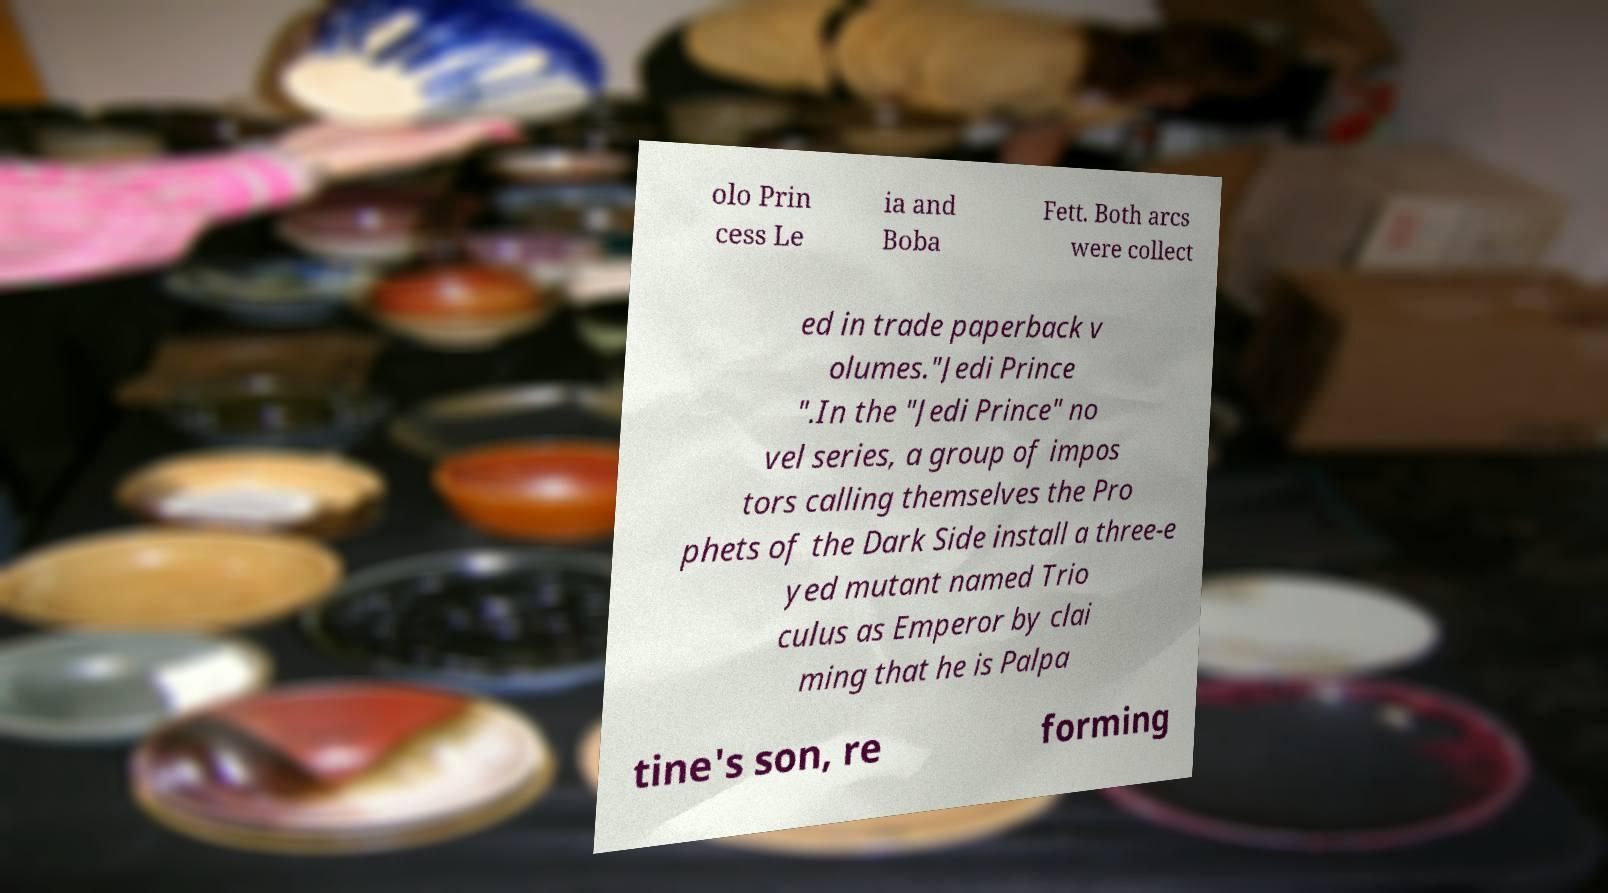Please identify and transcribe the text found in this image. olo Prin cess Le ia and Boba Fett. Both arcs were collect ed in trade paperback v olumes."Jedi Prince ".In the "Jedi Prince" no vel series, a group of impos tors calling themselves the Pro phets of the Dark Side install a three-e yed mutant named Trio culus as Emperor by clai ming that he is Palpa tine's son, re forming 